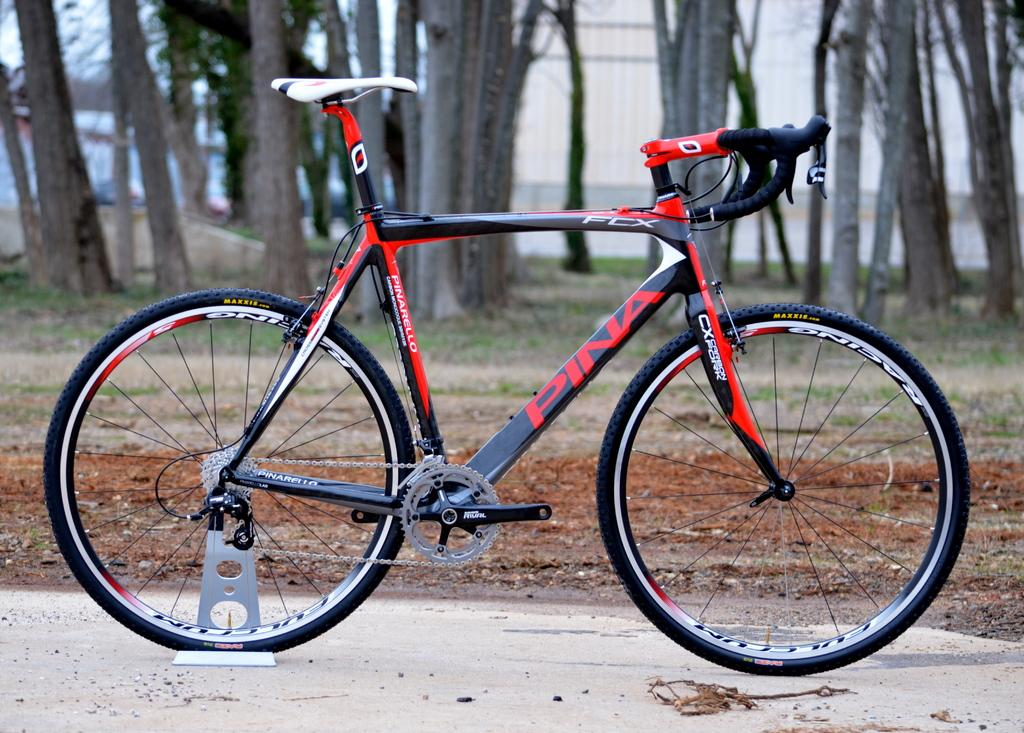What is the main object in the image? There is a bicycle in the image. What can be seen in the background of the image? There are trees in the image. How many cattle are grazing near the bicycle in the image? There are no cattle present in the image; it only features a bicycle and trees. 